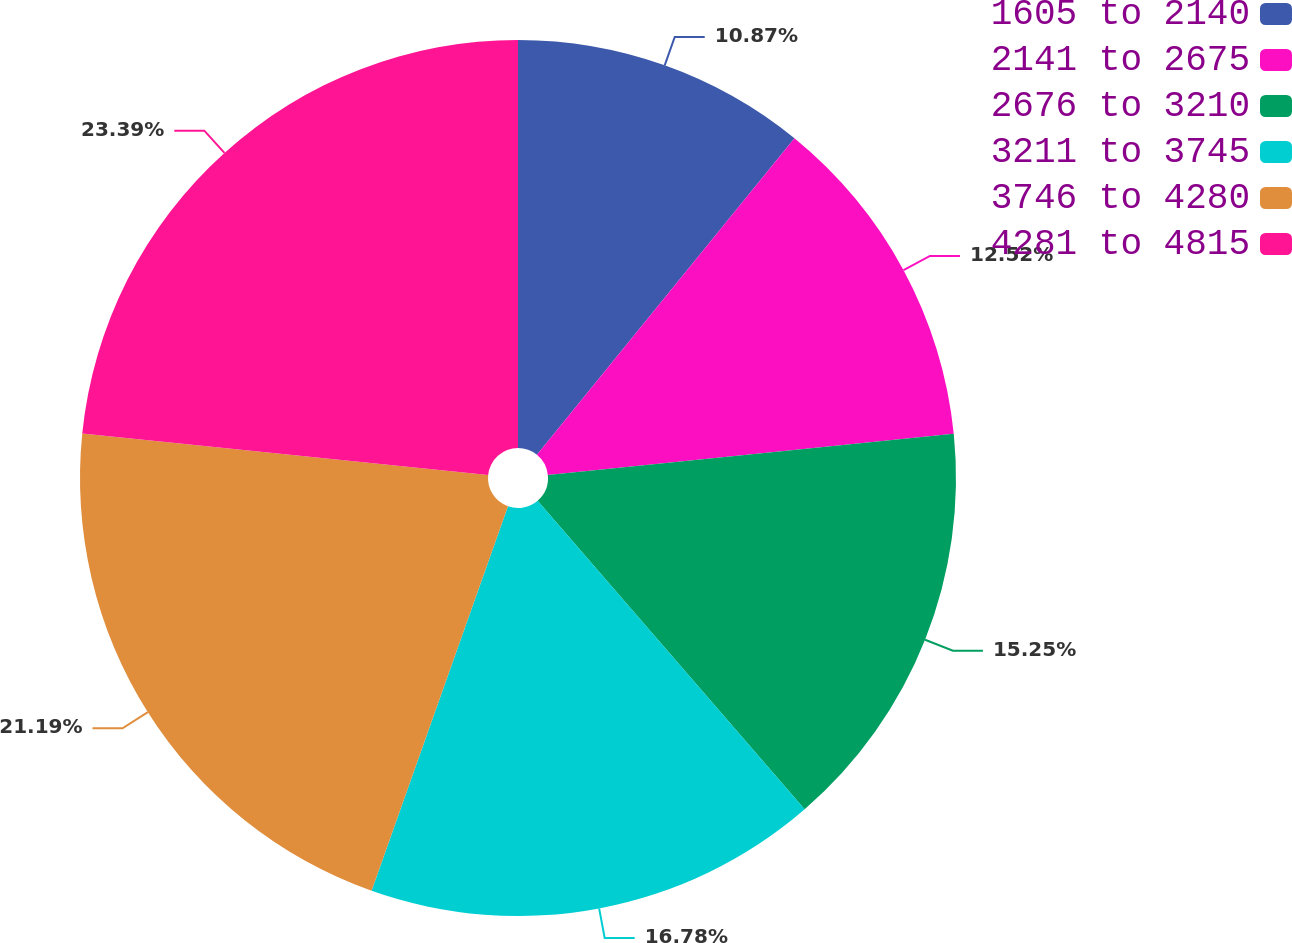Convert chart. <chart><loc_0><loc_0><loc_500><loc_500><pie_chart><fcel>1605 to 2140<fcel>2141 to 2675<fcel>2676 to 3210<fcel>3211 to 3745<fcel>3746 to 4280<fcel>4281 to 4815<nl><fcel>10.87%<fcel>12.52%<fcel>15.25%<fcel>16.78%<fcel>21.19%<fcel>23.38%<nl></chart> 